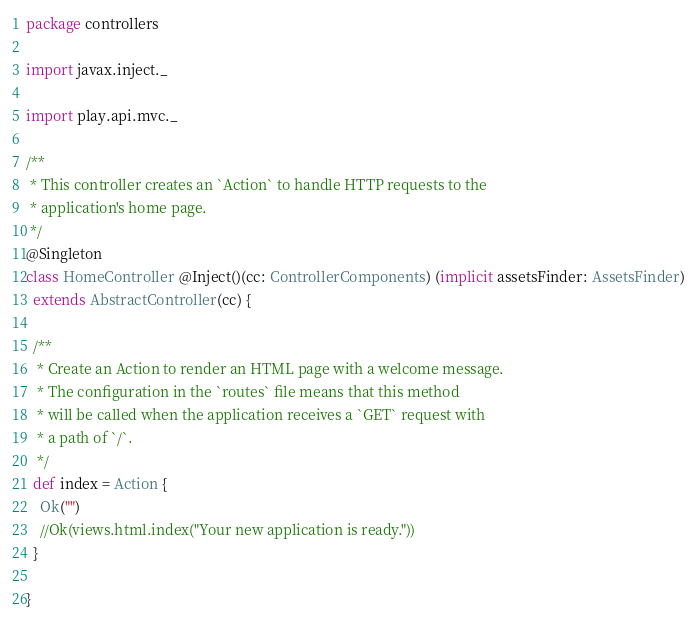<code> <loc_0><loc_0><loc_500><loc_500><_Scala_>package controllers

import javax.inject._

import play.api.mvc._

/**
 * This controller creates an `Action` to handle HTTP requests to the
 * application's home page.
 */
@Singleton
class HomeController @Inject()(cc: ControllerComponents) (implicit assetsFinder: AssetsFinder)
  extends AbstractController(cc) {

  /**
   * Create an Action to render an HTML page with a welcome message.
   * The configuration in the `routes` file means that this method
   * will be called when the application receives a `GET` request with
   * a path of `/`.
   */
  def index = Action {
    Ok("")
    //Ok(views.html.index("Your new application is ready."))
  }

}
</code> 